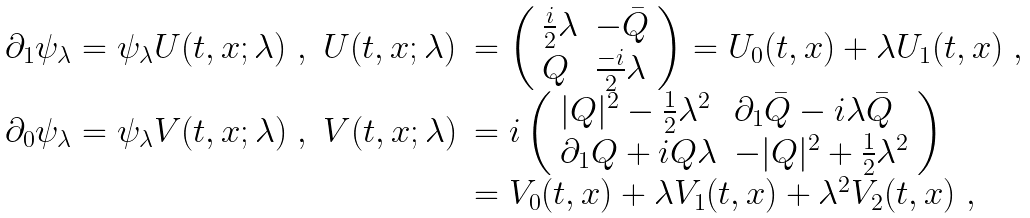<formula> <loc_0><loc_0><loc_500><loc_500>\begin{array} { l l l } \partial _ { 1 } \psi _ { \lambda } = \psi _ { \lambda } U ( t , x ; \lambda ) \ , & U ( t , x ; \lambda ) & = \left ( \begin{array} { l l } \frac { i } { 2 } \lambda & - \bar { Q } \\ Q & \frac { - i } { 2 } \lambda \end{array} \right ) = U _ { 0 } ( t , x ) + \lambda U _ { 1 } ( t , x ) \ , \\ \partial _ { 0 } \psi _ { \lambda } = \psi _ { \lambda } V ( t , x ; \lambda ) \ , & V ( t , x ; \lambda ) & = i \left ( \begin{array} { l l } | Q | ^ { 2 } - \frac { 1 } { 2 } \lambda ^ { 2 } & \partial _ { 1 } \bar { Q } - i \lambda \bar { Q } \\ \partial _ { 1 } Q + i Q \lambda & - | Q | ^ { 2 } + \frac { 1 } { 2 } \lambda ^ { 2 } \end{array} \right ) \\ & & = V _ { 0 } ( t , x ) + \lambda V _ { 1 } ( t , x ) + \lambda ^ { 2 } V _ { 2 } ( t , x ) \ , \end{array}</formula> 